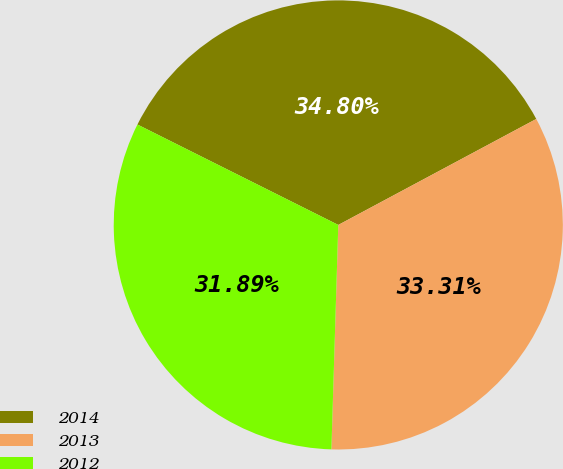Convert chart. <chart><loc_0><loc_0><loc_500><loc_500><pie_chart><fcel>2014<fcel>2013<fcel>2012<nl><fcel>34.8%<fcel>33.31%<fcel>31.89%<nl></chart> 